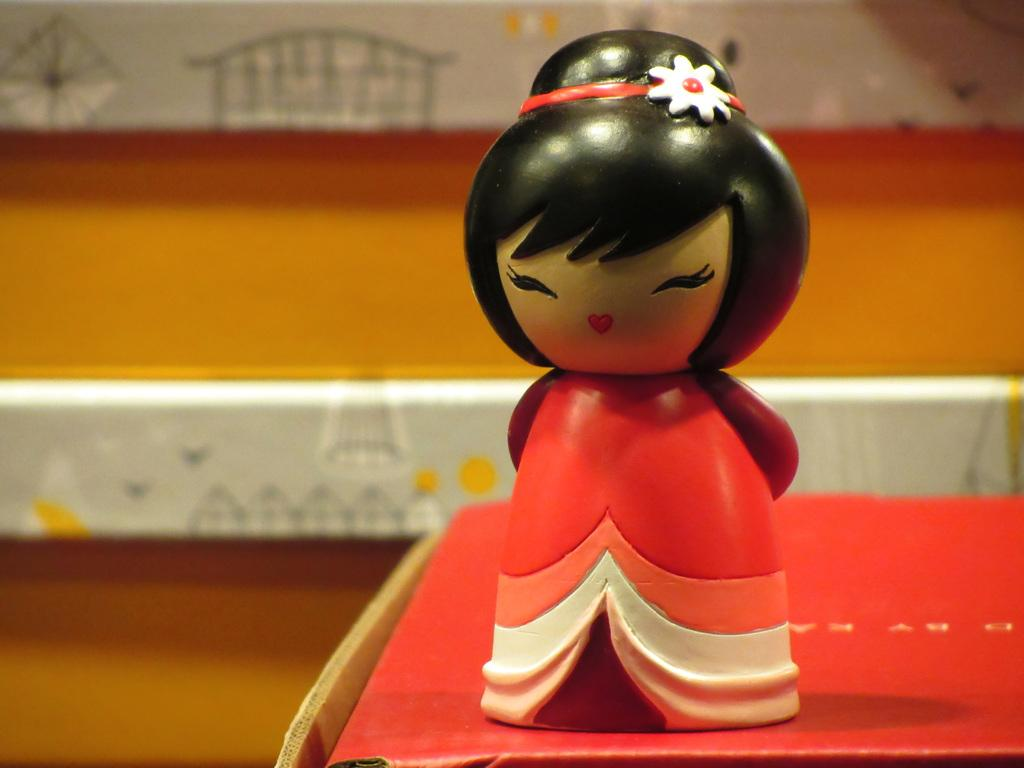What object is placed on a box in the image? There is a toy on a box on the right side of the image. What can be seen in the background of the image? There is a wall in the background of the image. What is on the wall in the image? There is a painting on the wall. What invention is being demonstrated in the image? There is no invention being demonstrated in the image; it features a toy on a box, a wall, and a painting on the wall. Can you see a bridge in the image? There is no bridge present in the image. 